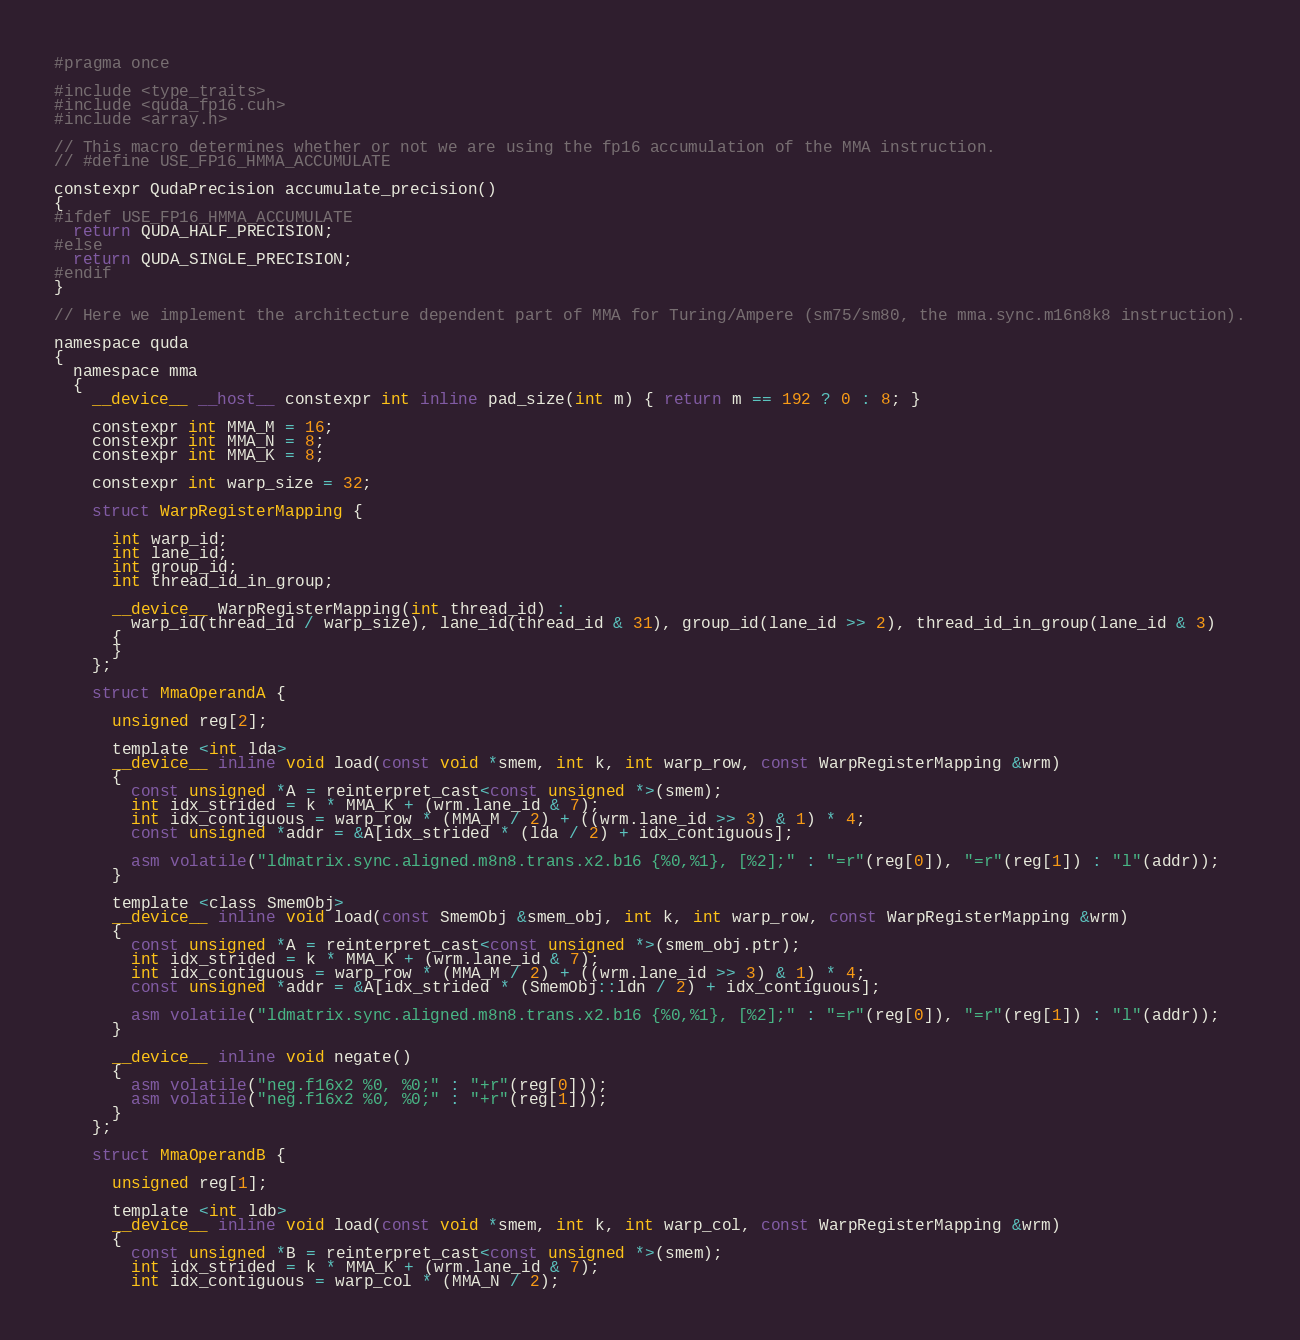<code> <loc_0><loc_0><loc_500><loc_500><_Cuda_>#pragma once

#include <type_traits>
#include <quda_fp16.cuh>
#include <array.h>

// This macro determines whether or not we are using the fp16 accumulation of the MMA instruction.
// #define USE_FP16_HMMA_ACCUMULATE

constexpr QudaPrecision accumulate_precision()
{
#ifdef USE_FP16_HMMA_ACCUMULATE
  return QUDA_HALF_PRECISION;
#else
  return QUDA_SINGLE_PRECISION;
#endif
}

// Here we implement the architecture dependent part of MMA for Turing/Ampere (sm75/sm80, the mma.sync.m16n8k8 instruction).

namespace quda
{
  namespace mma
  {
    __device__ __host__ constexpr int inline pad_size(int m) { return m == 192 ? 0 : 8; }

    constexpr int MMA_M = 16;
    constexpr int MMA_N = 8;
    constexpr int MMA_K = 8;

    constexpr int warp_size = 32;

    struct WarpRegisterMapping {

      int warp_id;
      int lane_id;
      int group_id;
      int thread_id_in_group;

      __device__ WarpRegisterMapping(int thread_id) :
        warp_id(thread_id / warp_size), lane_id(thread_id & 31), group_id(lane_id >> 2), thread_id_in_group(lane_id & 3)
      {
      }
    };

    struct MmaOperandA {

      unsigned reg[2];

      template <int lda>
      __device__ inline void load(const void *smem, int k, int warp_row, const WarpRegisterMapping &wrm)
      {
        const unsigned *A = reinterpret_cast<const unsigned *>(smem);
        int idx_strided = k * MMA_K + (wrm.lane_id & 7);
        int idx_contiguous = warp_row * (MMA_M / 2) + ((wrm.lane_id >> 3) & 1) * 4;
        const unsigned *addr = &A[idx_strided * (lda / 2) + idx_contiguous];

        asm volatile("ldmatrix.sync.aligned.m8n8.trans.x2.b16 {%0,%1}, [%2];" : "=r"(reg[0]), "=r"(reg[1]) : "l"(addr));
      }

      template <class SmemObj>
      __device__ inline void load(const SmemObj &smem_obj, int k, int warp_row, const WarpRegisterMapping &wrm)
      {
        const unsigned *A = reinterpret_cast<const unsigned *>(smem_obj.ptr);
        int idx_strided = k * MMA_K + (wrm.lane_id & 7);
        int idx_contiguous = warp_row * (MMA_M / 2) + ((wrm.lane_id >> 3) & 1) * 4;
        const unsigned *addr = &A[idx_strided * (SmemObj::ldn / 2) + idx_contiguous];

        asm volatile("ldmatrix.sync.aligned.m8n8.trans.x2.b16 {%0,%1}, [%2];" : "=r"(reg[0]), "=r"(reg[1]) : "l"(addr));
      }

      __device__ inline void negate()
      {
        asm volatile("neg.f16x2 %0, %0;" : "+r"(reg[0]));
        asm volatile("neg.f16x2 %0, %0;" : "+r"(reg[1]));
      }
    };

    struct MmaOperandB {

      unsigned reg[1];

      template <int ldb>
      __device__ inline void load(const void *smem, int k, int warp_col, const WarpRegisterMapping &wrm)
      {
        const unsigned *B = reinterpret_cast<const unsigned *>(smem);
        int idx_strided = k * MMA_K + (wrm.lane_id & 7);
        int idx_contiguous = warp_col * (MMA_N / 2);</code> 